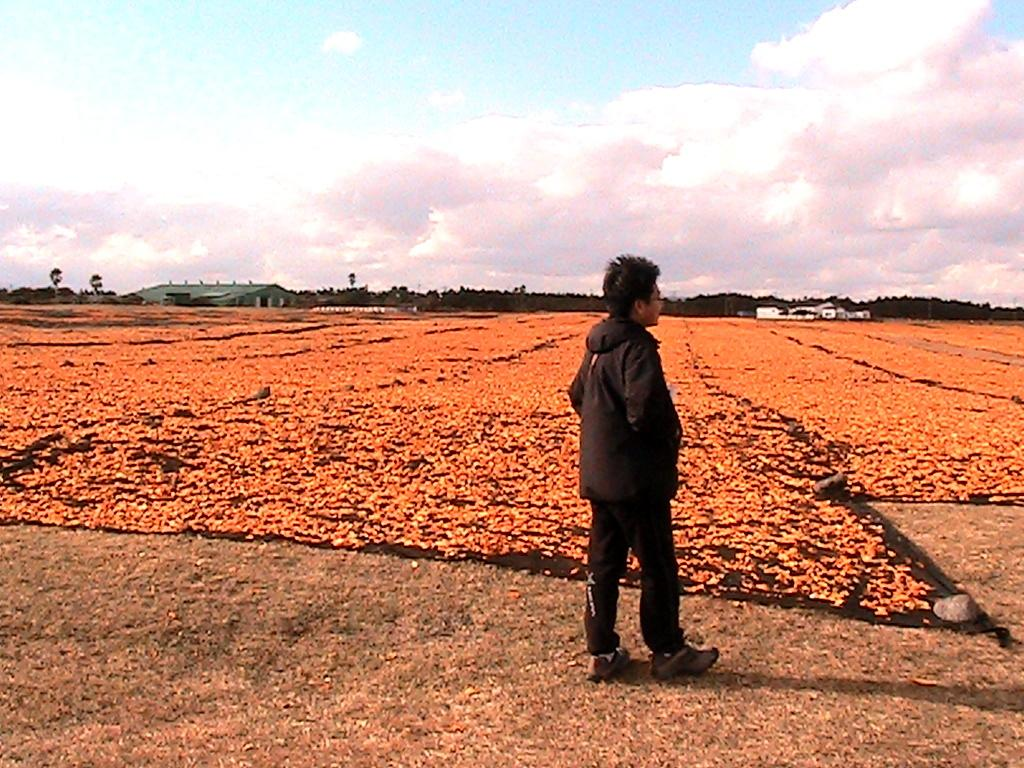What is the main subject of the image? There is a person standing in the center of the image. What is the person standing on? The person is standing on the ground. What can be seen in the background of the image? There are flowers, hills, buildings, trees, and the sky visible in the background of the image. Are there any clouds in the sky? Yes, there are clouds in the sky. What language is the person speaking in the image? There is no indication of the person speaking in the image, so we cannot determine the language. Is the person's father present in the image? There is no information about the person's father in the image, so we cannot determine if he is present. 